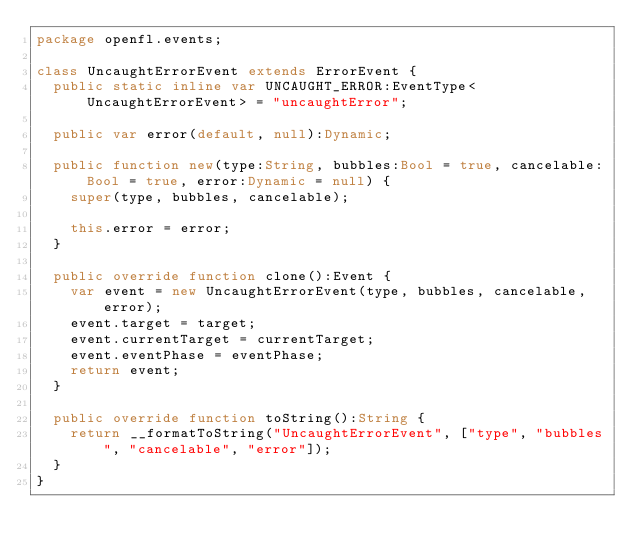<code> <loc_0><loc_0><loc_500><loc_500><_Haxe_>package openfl.events;

class UncaughtErrorEvent extends ErrorEvent {
	public static inline var UNCAUGHT_ERROR:EventType<UncaughtErrorEvent> = "uncaughtError";

	public var error(default, null):Dynamic;

	public function new(type:String, bubbles:Bool = true, cancelable:Bool = true, error:Dynamic = null) {
		super(type, bubbles, cancelable);

		this.error = error;
	}

	public override function clone():Event {
		var event = new UncaughtErrorEvent(type, bubbles, cancelable, error);
		event.target = target;
		event.currentTarget = currentTarget;
		event.eventPhase = eventPhase;
		return event;
	}

	public override function toString():String {
		return __formatToString("UncaughtErrorEvent", ["type", "bubbles", "cancelable", "error"]);
	}
}
</code> 